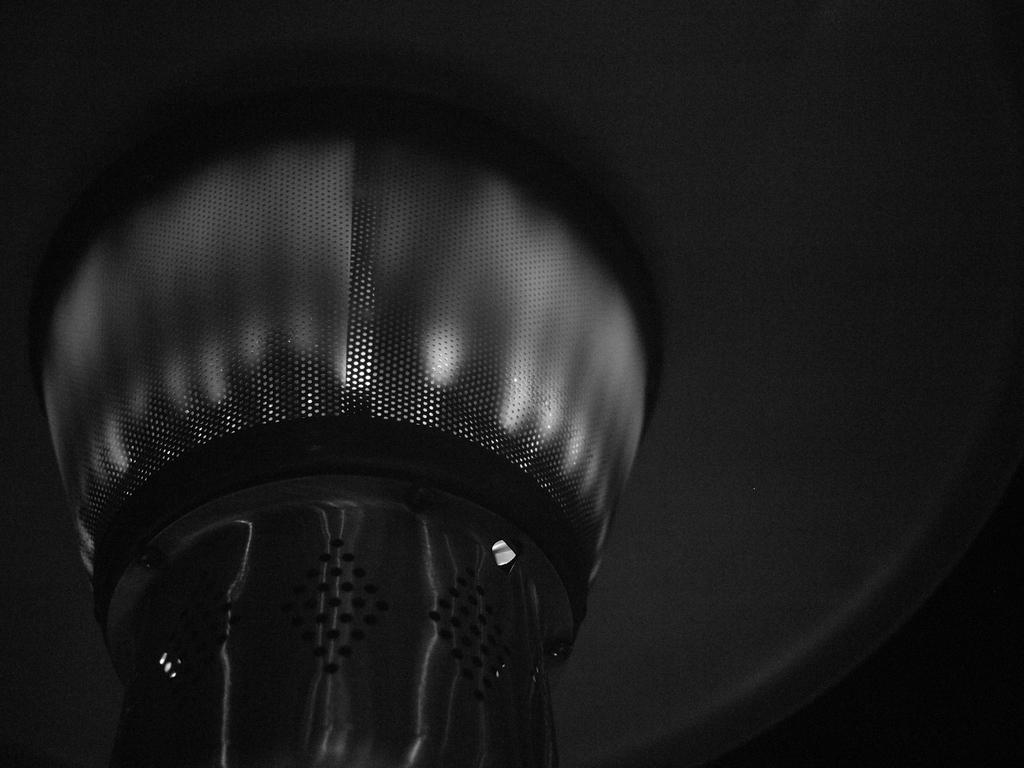What is the main subject of the image? The main subject of the image is a lamp. Can you describe the lamp in more detail? Unfortunately, the image is a close-up of the lamp, so it is difficult to provide more detail about its appearance. What type of reading material can be seen on the island in the aftermath of the storm? There is no reading material, island, or storm mentioned in the image. The image is a close-up of a lamp, and there is no context provided about the surrounding environment or any potential events. 